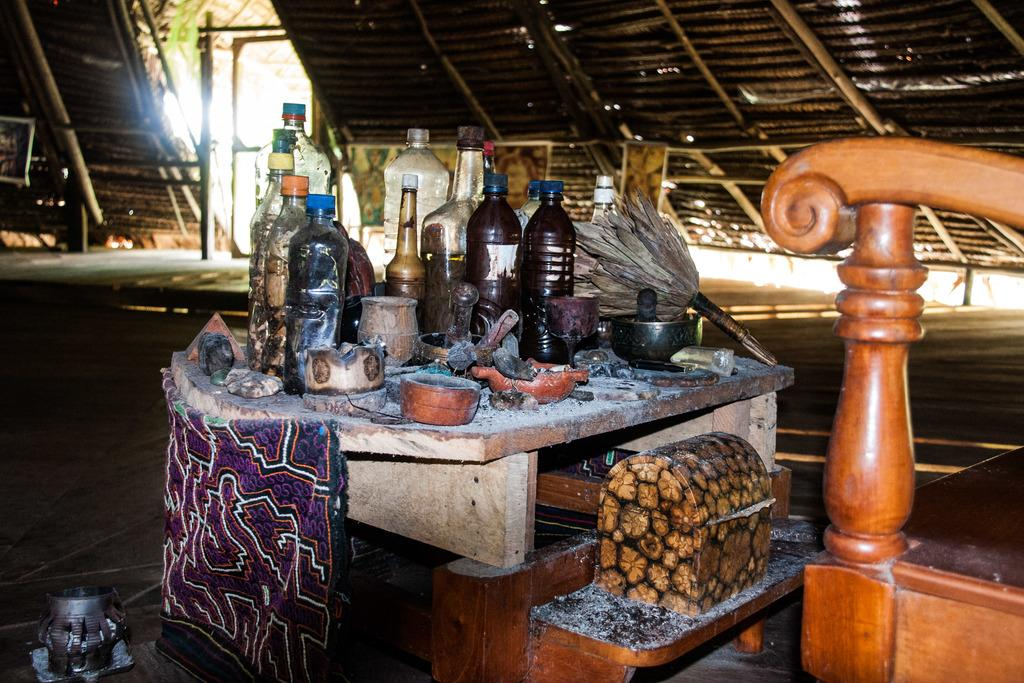What objects are present in the image? There are bottles in the image. What type of attraction can be seen in the background of the image? There is no background or attraction present in the image; it only features bottles. 